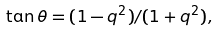<formula> <loc_0><loc_0><loc_500><loc_500>\tan \theta = ( 1 - q ^ { 2 } ) / ( 1 + q ^ { 2 } ) ,</formula> 